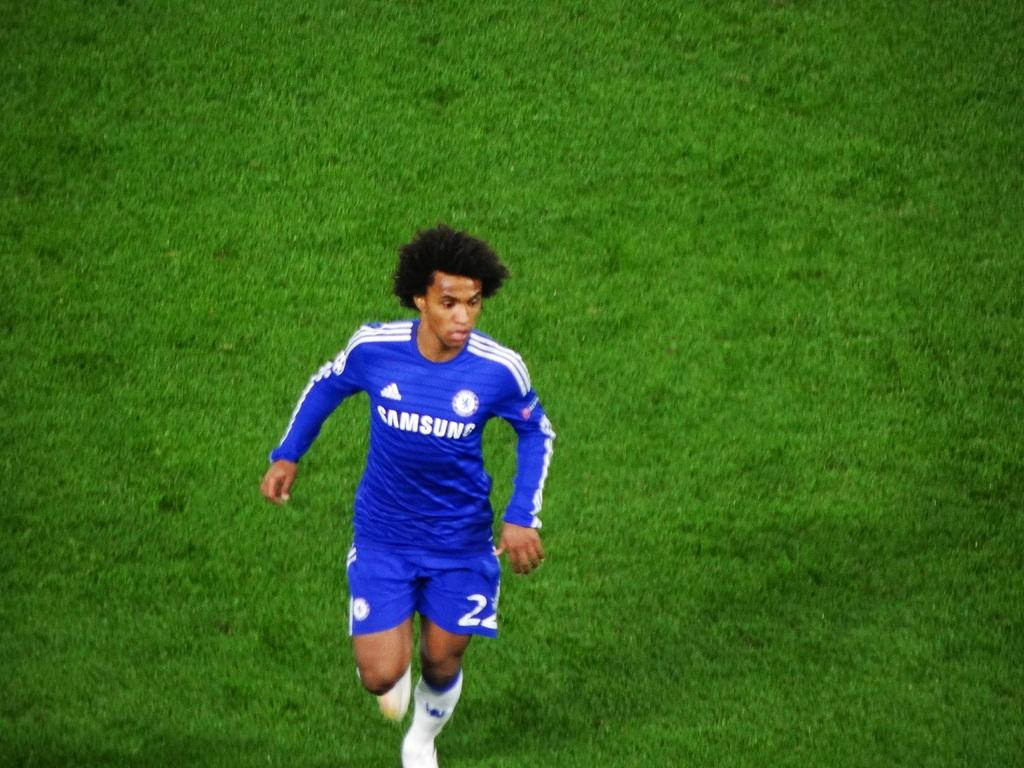<image>
Share a concise interpretation of the image provided. A soccer player in a Samsung uniform runs on a grassy field. 